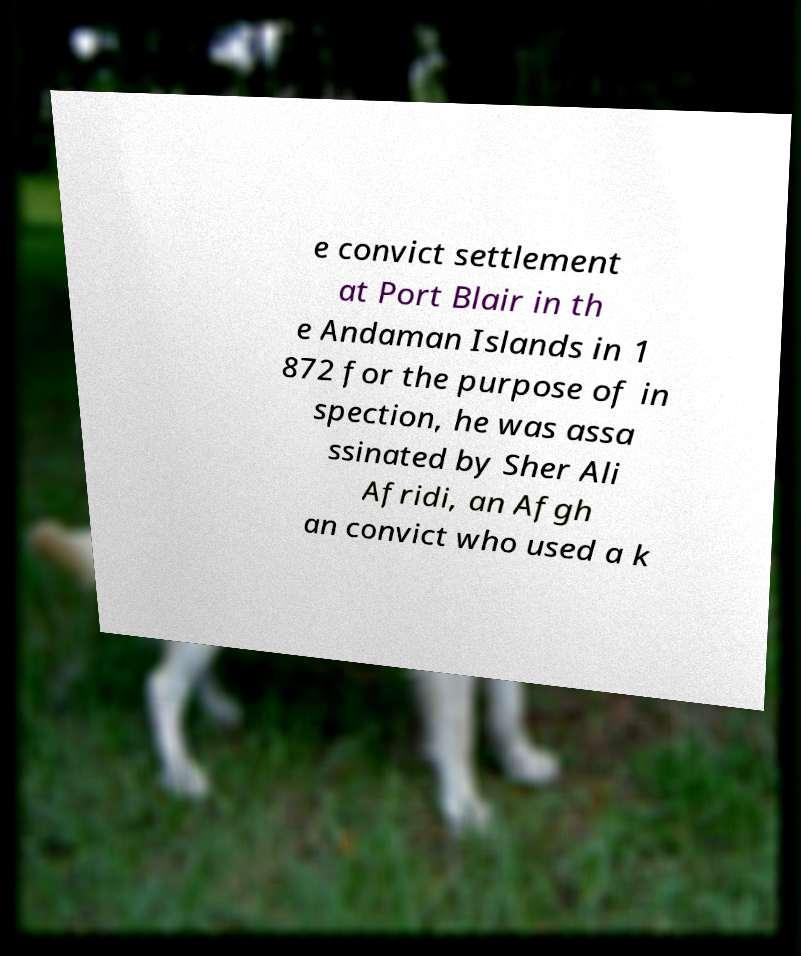Can you accurately transcribe the text from the provided image for me? e convict settlement at Port Blair in th e Andaman Islands in 1 872 for the purpose of in spection, he was assa ssinated by Sher Ali Afridi, an Afgh an convict who used a k 